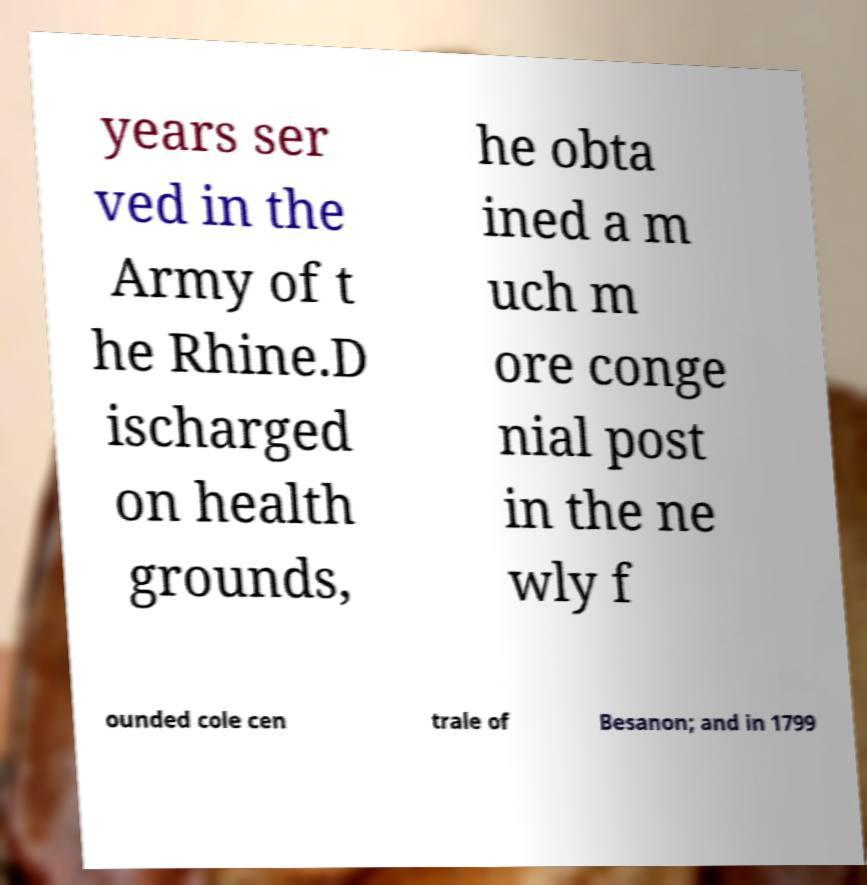Please read and relay the text visible in this image. What does it say? years ser ved in the Army of t he Rhine.D ischarged on health grounds, he obta ined a m uch m ore conge nial post in the ne wly f ounded cole cen trale of Besanon; and in 1799 